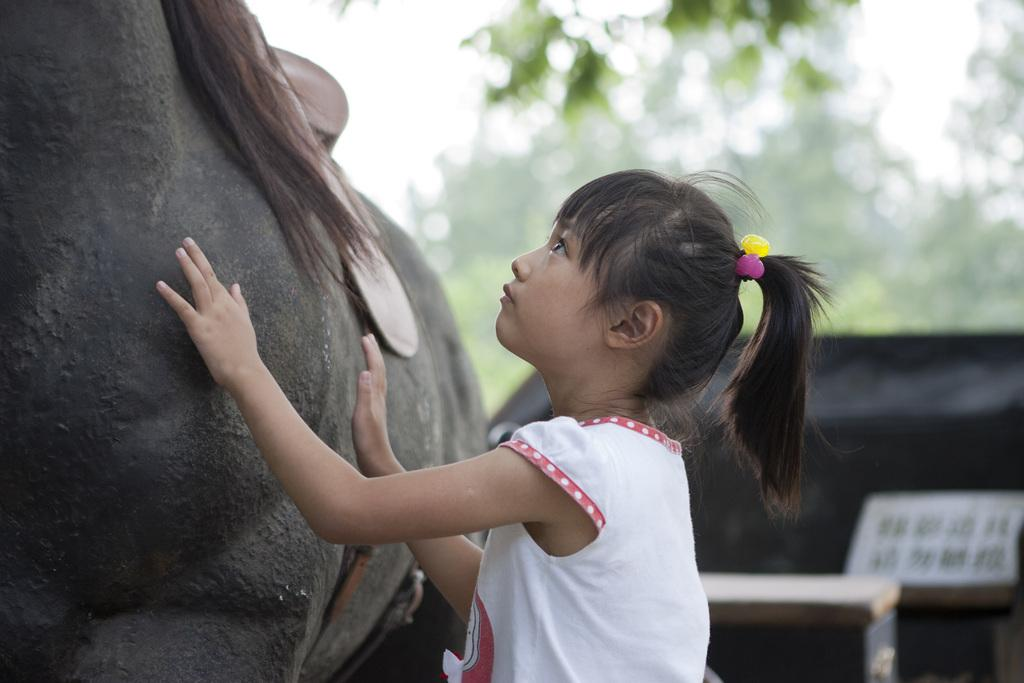Who is the main subject in the image? There is a girl in the image. What is in front of the girl? There is an animal in front of the girl. How would you describe the background of the image? The background of the image is blurry. Can you identify any objects in the background of the image? Yes, there are objects visible in the background of the image. What type of vase is being used as a prop by the girl in the image? There is no vase present in the image. How many slaves are visible in the image? There are no slaves present in the image. 